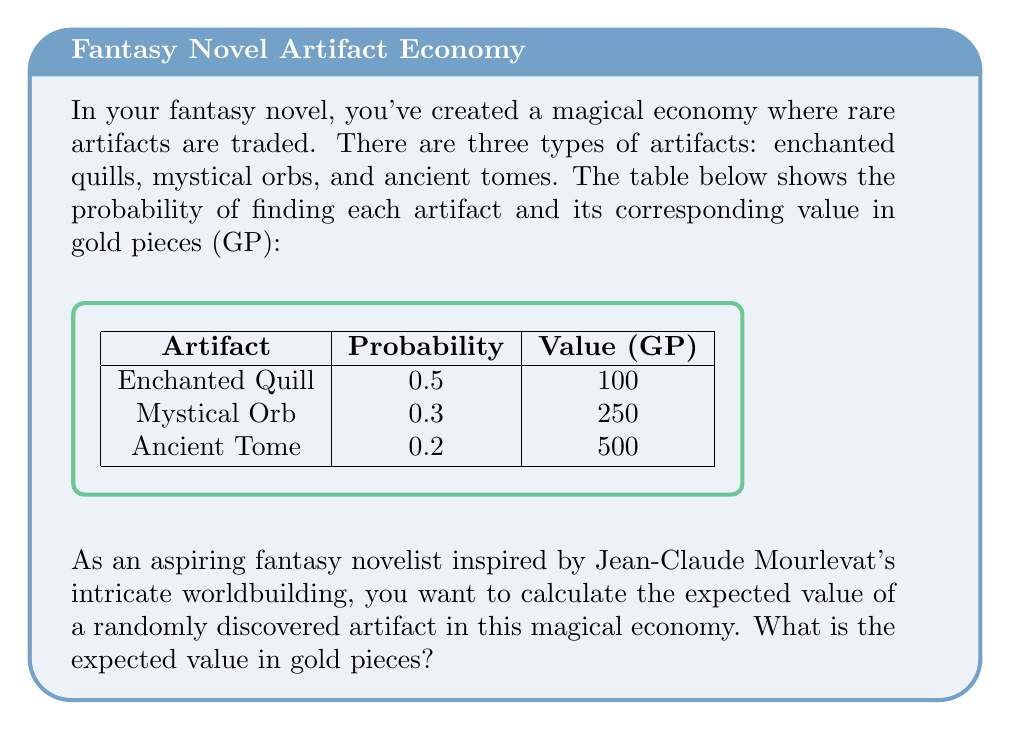Can you answer this question? To solve this problem, we need to calculate the expected value of the artifacts using the given probabilities and values. The expected value is the sum of each possible outcome multiplied by its probability.

Let's break it down step-by-step:

1) For the Enchanted Quill:
   Probability = 0.5
   Value = 100 GP
   Expected Value = $0.5 \times 100 = 50$ GP

2) For the Mystical Orb:
   Probability = 0.3
   Value = 250 GP
   Expected Value = $0.3 \times 250 = 75$ GP

3) For the Ancient Tome:
   Probability = 0.2
   Value = 500 GP
   Expected Value = $0.2 \times 500 = 100$ GP

4) The total expected value is the sum of these individual expected values:

   $E(\text{artifact}) = 50 + 75 + 100 = 225$ GP

Therefore, the expected value of a randomly discovered artifact in this magical economy is 225 gold pieces.

We can also express this mathematically as:

$$E(\text{artifact}) = \sum_{i=1}^{n} p_i \times v_i$$

Where $p_i$ is the probability of finding artifact $i$, and $v_i$ is its value.

$$E(\text{artifact}) = (0.5 \times 100) + (0.3 \times 250) + (0.2 \times 500) = 225$$

This expected value can help you, as a fantasy novelist, to create a balanced magical economy in your story, ensuring that the discovery of artifacts feels rewarding yet not overpowered.
Answer: 225 GP 